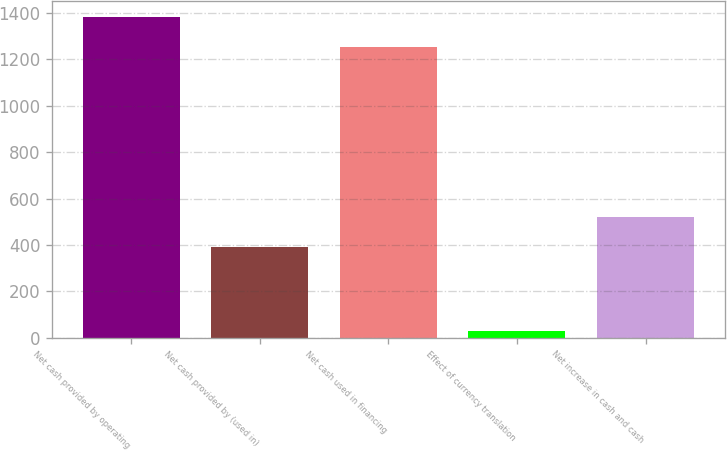<chart> <loc_0><loc_0><loc_500><loc_500><bar_chart><fcel>Net cash provided by operating<fcel>Net cash provided by (used in)<fcel>Net cash used in financing<fcel>Effect of currency translation<fcel>Net increase in cash and cash<nl><fcel>1383.8<fcel>391<fcel>1254<fcel>31<fcel>520.8<nl></chart> 